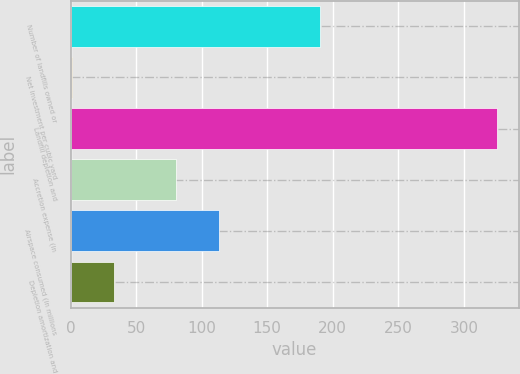Convert chart to OTSL. <chart><loc_0><loc_0><loc_500><loc_500><bar_chart><fcel>Number of landfills owned or<fcel>Net investment per cubic yard<fcel>Landfill depletion and<fcel>Accretion expense (in<fcel>Airspace consumed (in millions<fcel>Depletion amortization and<nl><fcel>190<fcel>0.74<fcel>325.6<fcel>80.7<fcel>113.19<fcel>33.23<nl></chart> 